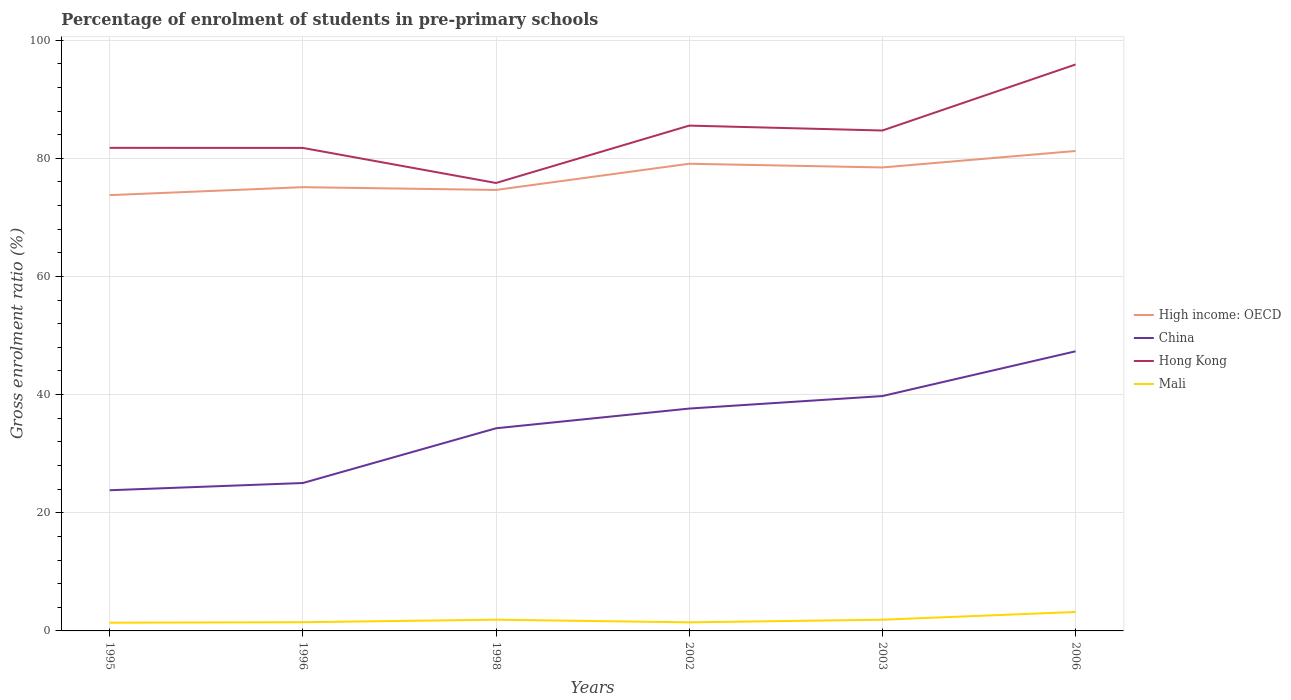How many different coloured lines are there?
Offer a very short reply. 4. Does the line corresponding to Hong Kong intersect with the line corresponding to High income: OECD?
Your answer should be very brief. No. Is the number of lines equal to the number of legend labels?
Offer a very short reply. Yes. Across all years, what is the maximum percentage of students enrolled in pre-primary schools in Hong Kong?
Your answer should be compact. 75.83. What is the total percentage of students enrolled in pre-primary schools in Hong Kong in the graph?
Make the answer very short. 0.01. What is the difference between the highest and the second highest percentage of students enrolled in pre-primary schools in China?
Your answer should be compact. 23.52. Is the percentage of students enrolled in pre-primary schools in Hong Kong strictly greater than the percentage of students enrolled in pre-primary schools in Mali over the years?
Your response must be concise. No. What is the difference between two consecutive major ticks on the Y-axis?
Give a very brief answer. 20. Are the values on the major ticks of Y-axis written in scientific E-notation?
Your response must be concise. No. Does the graph contain any zero values?
Provide a succinct answer. No. What is the title of the graph?
Make the answer very short. Percentage of enrolment of students in pre-primary schools. What is the label or title of the X-axis?
Your response must be concise. Years. What is the Gross enrolment ratio (%) of High income: OECD in 1995?
Offer a terse response. 73.77. What is the Gross enrolment ratio (%) in China in 1995?
Offer a very short reply. 23.81. What is the Gross enrolment ratio (%) in Hong Kong in 1995?
Provide a short and direct response. 81.78. What is the Gross enrolment ratio (%) of Mali in 1995?
Make the answer very short. 1.39. What is the Gross enrolment ratio (%) in High income: OECD in 1996?
Offer a very short reply. 75.12. What is the Gross enrolment ratio (%) of China in 1996?
Offer a terse response. 25.04. What is the Gross enrolment ratio (%) of Hong Kong in 1996?
Your answer should be very brief. 81.76. What is the Gross enrolment ratio (%) of Mali in 1996?
Provide a short and direct response. 1.47. What is the Gross enrolment ratio (%) in High income: OECD in 1998?
Keep it short and to the point. 74.65. What is the Gross enrolment ratio (%) in China in 1998?
Offer a very short reply. 34.31. What is the Gross enrolment ratio (%) in Hong Kong in 1998?
Offer a very short reply. 75.83. What is the Gross enrolment ratio (%) of Mali in 1998?
Offer a terse response. 1.9. What is the Gross enrolment ratio (%) in High income: OECD in 2002?
Your response must be concise. 79.08. What is the Gross enrolment ratio (%) in China in 2002?
Provide a succinct answer. 37.64. What is the Gross enrolment ratio (%) in Hong Kong in 2002?
Offer a very short reply. 85.54. What is the Gross enrolment ratio (%) in Mali in 2002?
Your answer should be very brief. 1.45. What is the Gross enrolment ratio (%) of High income: OECD in 2003?
Offer a very short reply. 78.46. What is the Gross enrolment ratio (%) in China in 2003?
Ensure brevity in your answer.  39.76. What is the Gross enrolment ratio (%) in Hong Kong in 2003?
Ensure brevity in your answer.  84.71. What is the Gross enrolment ratio (%) in Mali in 2003?
Your answer should be very brief. 1.9. What is the Gross enrolment ratio (%) in High income: OECD in 2006?
Offer a very short reply. 81.24. What is the Gross enrolment ratio (%) in China in 2006?
Keep it short and to the point. 47.34. What is the Gross enrolment ratio (%) in Hong Kong in 2006?
Give a very brief answer. 95.89. What is the Gross enrolment ratio (%) in Mali in 2006?
Offer a terse response. 3.21. Across all years, what is the maximum Gross enrolment ratio (%) in High income: OECD?
Make the answer very short. 81.24. Across all years, what is the maximum Gross enrolment ratio (%) in China?
Offer a terse response. 47.34. Across all years, what is the maximum Gross enrolment ratio (%) of Hong Kong?
Offer a terse response. 95.89. Across all years, what is the maximum Gross enrolment ratio (%) in Mali?
Offer a very short reply. 3.21. Across all years, what is the minimum Gross enrolment ratio (%) in High income: OECD?
Offer a very short reply. 73.77. Across all years, what is the minimum Gross enrolment ratio (%) of China?
Provide a short and direct response. 23.81. Across all years, what is the minimum Gross enrolment ratio (%) of Hong Kong?
Keep it short and to the point. 75.83. Across all years, what is the minimum Gross enrolment ratio (%) of Mali?
Provide a succinct answer. 1.39. What is the total Gross enrolment ratio (%) of High income: OECD in the graph?
Your answer should be very brief. 462.32. What is the total Gross enrolment ratio (%) of China in the graph?
Your response must be concise. 207.89. What is the total Gross enrolment ratio (%) in Hong Kong in the graph?
Offer a very short reply. 505.5. What is the total Gross enrolment ratio (%) in Mali in the graph?
Give a very brief answer. 11.33. What is the difference between the Gross enrolment ratio (%) in High income: OECD in 1995 and that in 1996?
Your response must be concise. -1.35. What is the difference between the Gross enrolment ratio (%) in China in 1995 and that in 1996?
Provide a short and direct response. -1.22. What is the difference between the Gross enrolment ratio (%) of Hong Kong in 1995 and that in 1996?
Give a very brief answer. 0.01. What is the difference between the Gross enrolment ratio (%) in Mali in 1995 and that in 1996?
Your answer should be compact. -0.08. What is the difference between the Gross enrolment ratio (%) in High income: OECD in 1995 and that in 1998?
Offer a very short reply. -0.88. What is the difference between the Gross enrolment ratio (%) in China in 1995 and that in 1998?
Ensure brevity in your answer.  -10.49. What is the difference between the Gross enrolment ratio (%) of Hong Kong in 1995 and that in 1998?
Keep it short and to the point. 5.95. What is the difference between the Gross enrolment ratio (%) in Mali in 1995 and that in 1998?
Make the answer very short. -0.51. What is the difference between the Gross enrolment ratio (%) in High income: OECD in 1995 and that in 2002?
Ensure brevity in your answer.  -5.31. What is the difference between the Gross enrolment ratio (%) of China in 1995 and that in 2002?
Your answer should be very brief. -13.83. What is the difference between the Gross enrolment ratio (%) in Hong Kong in 1995 and that in 2002?
Keep it short and to the point. -3.76. What is the difference between the Gross enrolment ratio (%) of Mali in 1995 and that in 2002?
Your answer should be very brief. -0.06. What is the difference between the Gross enrolment ratio (%) of High income: OECD in 1995 and that in 2003?
Make the answer very short. -4.69. What is the difference between the Gross enrolment ratio (%) of China in 1995 and that in 2003?
Give a very brief answer. -15.94. What is the difference between the Gross enrolment ratio (%) of Hong Kong in 1995 and that in 2003?
Offer a terse response. -2.94. What is the difference between the Gross enrolment ratio (%) in Mali in 1995 and that in 2003?
Provide a short and direct response. -0.51. What is the difference between the Gross enrolment ratio (%) of High income: OECD in 1995 and that in 2006?
Your answer should be compact. -7.47. What is the difference between the Gross enrolment ratio (%) of China in 1995 and that in 2006?
Provide a succinct answer. -23.52. What is the difference between the Gross enrolment ratio (%) in Hong Kong in 1995 and that in 2006?
Ensure brevity in your answer.  -14.11. What is the difference between the Gross enrolment ratio (%) of Mali in 1995 and that in 2006?
Make the answer very short. -1.81. What is the difference between the Gross enrolment ratio (%) in High income: OECD in 1996 and that in 1998?
Ensure brevity in your answer.  0.47. What is the difference between the Gross enrolment ratio (%) in China in 1996 and that in 1998?
Provide a short and direct response. -9.27. What is the difference between the Gross enrolment ratio (%) in Hong Kong in 1996 and that in 1998?
Make the answer very short. 5.93. What is the difference between the Gross enrolment ratio (%) in Mali in 1996 and that in 1998?
Your answer should be very brief. -0.43. What is the difference between the Gross enrolment ratio (%) in High income: OECD in 1996 and that in 2002?
Ensure brevity in your answer.  -3.97. What is the difference between the Gross enrolment ratio (%) in China in 1996 and that in 2002?
Your answer should be compact. -12.6. What is the difference between the Gross enrolment ratio (%) in Hong Kong in 1996 and that in 2002?
Keep it short and to the point. -3.78. What is the difference between the Gross enrolment ratio (%) in Mali in 1996 and that in 2002?
Give a very brief answer. 0.02. What is the difference between the Gross enrolment ratio (%) of High income: OECD in 1996 and that in 2003?
Your answer should be very brief. -3.34. What is the difference between the Gross enrolment ratio (%) of China in 1996 and that in 2003?
Keep it short and to the point. -14.72. What is the difference between the Gross enrolment ratio (%) in Hong Kong in 1996 and that in 2003?
Give a very brief answer. -2.95. What is the difference between the Gross enrolment ratio (%) of Mali in 1996 and that in 2003?
Make the answer very short. -0.42. What is the difference between the Gross enrolment ratio (%) in High income: OECD in 1996 and that in 2006?
Make the answer very short. -6.13. What is the difference between the Gross enrolment ratio (%) in China in 1996 and that in 2006?
Your answer should be compact. -22.3. What is the difference between the Gross enrolment ratio (%) in Hong Kong in 1996 and that in 2006?
Offer a very short reply. -14.12. What is the difference between the Gross enrolment ratio (%) in Mali in 1996 and that in 2006?
Ensure brevity in your answer.  -1.73. What is the difference between the Gross enrolment ratio (%) of High income: OECD in 1998 and that in 2002?
Your answer should be very brief. -4.43. What is the difference between the Gross enrolment ratio (%) of China in 1998 and that in 2002?
Give a very brief answer. -3.33. What is the difference between the Gross enrolment ratio (%) in Hong Kong in 1998 and that in 2002?
Offer a terse response. -9.71. What is the difference between the Gross enrolment ratio (%) of Mali in 1998 and that in 2002?
Your answer should be compact. 0.45. What is the difference between the Gross enrolment ratio (%) of High income: OECD in 1998 and that in 2003?
Keep it short and to the point. -3.81. What is the difference between the Gross enrolment ratio (%) of China in 1998 and that in 2003?
Keep it short and to the point. -5.45. What is the difference between the Gross enrolment ratio (%) in Hong Kong in 1998 and that in 2003?
Give a very brief answer. -8.88. What is the difference between the Gross enrolment ratio (%) of Mali in 1998 and that in 2003?
Provide a short and direct response. 0. What is the difference between the Gross enrolment ratio (%) of High income: OECD in 1998 and that in 2006?
Make the answer very short. -6.59. What is the difference between the Gross enrolment ratio (%) in China in 1998 and that in 2006?
Keep it short and to the point. -13.03. What is the difference between the Gross enrolment ratio (%) of Hong Kong in 1998 and that in 2006?
Make the answer very short. -20.06. What is the difference between the Gross enrolment ratio (%) of Mali in 1998 and that in 2006?
Provide a succinct answer. -1.3. What is the difference between the Gross enrolment ratio (%) in High income: OECD in 2002 and that in 2003?
Keep it short and to the point. 0.63. What is the difference between the Gross enrolment ratio (%) in China in 2002 and that in 2003?
Offer a terse response. -2.12. What is the difference between the Gross enrolment ratio (%) of Hong Kong in 2002 and that in 2003?
Ensure brevity in your answer.  0.83. What is the difference between the Gross enrolment ratio (%) in Mali in 2002 and that in 2003?
Provide a short and direct response. -0.45. What is the difference between the Gross enrolment ratio (%) of High income: OECD in 2002 and that in 2006?
Your answer should be very brief. -2.16. What is the difference between the Gross enrolment ratio (%) of China in 2002 and that in 2006?
Offer a very short reply. -9.7. What is the difference between the Gross enrolment ratio (%) in Hong Kong in 2002 and that in 2006?
Your answer should be very brief. -10.35. What is the difference between the Gross enrolment ratio (%) in Mali in 2002 and that in 2006?
Make the answer very short. -1.75. What is the difference between the Gross enrolment ratio (%) in High income: OECD in 2003 and that in 2006?
Your answer should be very brief. -2.79. What is the difference between the Gross enrolment ratio (%) in China in 2003 and that in 2006?
Keep it short and to the point. -7.58. What is the difference between the Gross enrolment ratio (%) of Hong Kong in 2003 and that in 2006?
Ensure brevity in your answer.  -11.18. What is the difference between the Gross enrolment ratio (%) in Mali in 2003 and that in 2006?
Give a very brief answer. -1.31. What is the difference between the Gross enrolment ratio (%) of High income: OECD in 1995 and the Gross enrolment ratio (%) of China in 1996?
Keep it short and to the point. 48.73. What is the difference between the Gross enrolment ratio (%) of High income: OECD in 1995 and the Gross enrolment ratio (%) of Hong Kong in 1996?
Give a very brief answer. -7.99. What is the difference between the Gross enrolment ratio (%) of High income: OECD in 1995 and the Gross enrolment ratio (%) of Mali in 1996?
Ensure brevity in your answer.  72.3. What is the difference between the Gross enrolment ratio (%) of China in 1995 and the Gross enrolment ratio (%) of Hong Kong in 1996?
Your answer should be compact. -57.95. What is the difference between the Gross enrolment ratio (%) of China in 1995 and the Gross enrolment ratio (%) of Mali in 1996?
Your answer should be compact. 22.34. What is the difference between the Gross enrolment ratio (%) in Hong Kong in 1995 and the Gross enrolment ratio (%) in Mali in 1996?
Ensure brevity in your answer.  80.3. What is the difference between the Gross enrolment ratio (%) of High income: OECD in 1995 and the Gross enrolment ratio (%) of China in 1998?
Give a very brief answer. 39.46. What is the difference between the Gross enrolment ratio (%) of High income: OECD in 1995 and the Gross enrolment ratio (%) of Hong Kong in 1998?
Your response must be concise. -2.06. What is the difference between the Gross enrolment ratio (%) in High income: OECD in 1995 and the Gross enrolment ratio (%) in Mali in 1998?
Your answer should be very brief. 71.87. What is the difference between the Gross enrolment ratio (%) of China in 1995 and the Gross enrolment ratio (%) of Hong Kong in 1998?
Provide a succinct answer. -52.01. What is the difference between the Gross enrolment ratio (%) in China in 1995 and the Gross enrolment ratio (%) in Mali in 1998?
Ensure brevity in your answer.  21.91. What is the difference between the Gross enrolment ratio (%) of Hong Kong in 1995 and the Gross enrolment ratio (%) of Mali in 1998?
Ensure brevity in your answer.  79.87. What is the difference between the Gross enrolment ratio (%) of High income: OECD in 1995 and the Gross enrolment ratio (%) of China in 2002?
Keep it short and to the point. 36.13. What is the difference between the Gross enrolment ratio (%) of High income: OECD in 1995 and the Gross enrolment ratio (%) of Hong Kong in 2002?
Your answer should be very brief. -11.77. What is the difference between the Gross enrolment ratio (%) of High income: OECD in 1995 and the Gross enrolment ratio (%) of Mali in 2002?
Offer a very short reply. 72.32. What is the difference between the Gross enrolment ratio (%) of China in 1995 and the Gross enrolment ratio (%) of Hong Kong in 2002?
Provide a short and direct response. -61.72. What is the difference between the Gross enrolment ratio (%) of China in 1995 and the Gross enrolment ratio (%) of Mali in 2002?
Your response must be concise. 22.36. What is the difference between the Gross enrolment ratio (%) of Hong Kong in 1995 and the Gross enrolment ratio (%) of Mali in 2002?
Your response must be concise. 80.32. What is the difference between the Gross enrolment ratio (%) of High income: OECD in 1995 and the Gross enrolment ratio (%) of China in 2003?
Provide a succinct answer. 34.01. What is the difference between the Gross enrolment ratio (%) in High income: OECD in 1995 and the Gross enrolment ratio (%) in Hong Kong in 2003?
Offer a very short reply. -10.94. What is the difference between the Gross enrolment ratio (%) in High income: OECD in 1995 and the Gross enrolment ratio (%) in Mali in 2003?
Offer a terse response. 71.87. What is the difference between the Gross enrolment ratio (%) in China in 1995 and the Gross enrolment ratio (%) in Hong Kong in 2003?
Offer a terse response. -60.9. What is the difference between the Gross enrolment ratio (%) in China in 1995 and the Gross enrolment ratio (%) in Mali in 2003?
Ensure brevity in your answer.  21.92. What is the difference between the Gross enrolment ratio (%) in Hong Kong in 1995 and the Gross enrolment ratio (%) in Mali in 2003?
Ensure brevity in your answer.  79.88. What is the difference between the Gross enrolment ratio (%) of High income: OECD in 1995 and the Gross enrolment ratio (%) of China in 2006?
Offer a very short reply. 26.43. What is the difference between the Gross enrolment ratio (%) in High income: OECD in 1995 and the Gross enrolment ratio (%) in Hong Kong in 2006?
Provide a succinct answer. -22.12. What is the difference between the Gross enrolment ratio (%) in High income: OECD in 1995 and the Gross enrolment ratio (%) in Mali in 2006?
Provide a succinct answer. 70.56. What is the difference between the Gross enrolment ratio (%) of China in 1995 and the Gross enrolment ratio (%) of Hong Kong in 2006?
Offer a very short reply. -72.07. What is the difference between the Gross enrolment ratio (%) in China in 1995 and the Gross enrolment ratio (%) in Mali in 2006?
Give a very brief answer. 20.61. What is the difference between the Gross enrolment ratio (%) in Hong Kong in 1995 and the Gross enrolment ratio (%) in Mali in 2006?
Your answer should be very brief. 78.57. What is the difference between the Gross enrolment ratio (%) in High income: OECD in 1996 and the Gross enrolment ratio (%) in China in 1998?
Your answer should be compact. 40.81. What is the difference between the Gross enrolment ratio (%) of High income: OECD in 1996 and the Gross enrolment ratio (%) of Hong Kong in 1998?
Ensure brevity in your answer.  -0.71. What is the difference between the Gross enrolment ratio (%) in High income: OECD in 1996 and the Gross enrolment ratio (%) in Mali in 1998?
Keep it short and to the point. 73.22. What is the difference between the Gross enrolment ratio (%) of China in 1996 and the Gross enrolment ratio (%) of Hong Kong in 1998?
Your answer should be compact. -50.79. What is the difference between the Gross enrolment ratio (%) of China in 1996 and the Gross enrolment ratio (%) of Mali in 1998?
Keep it short and to the point. 23.13. What is the difference between the Gross enrolment ratio (%) of Hong Kong in 1996 and the Gross enrolment ratio (%) of Mali in 1998?
Your answer should be compact. 79.86. What is the difference between the Gross enrolment ratio (%) in High income: OECD in 1996 and the Gross enrolment ratio (%) in China in 2002?
Provide a succinct answer. 37.48. What is the difference between the Gross enrolment ratio (%) in High income: OECD in 1996 and the Gross enrolment ratio (%) in Hong Kong in 2002?
Offer a terse response. -10.42. What is the difference between the Gross enrolment ratio (%) in High income: OECD in 1996 and the Gross enrolment ratio (%) in Mali in 2002?
Provide a short and direct response. 73.67. What is the difference between the Gross enrolment ratio (%) of China in 1996 and the Gross enrolment ratio (%) of Hong Kong in 2002?
Make the answer very short. -60.5. What is the difference between the Gross enrolment ratio (%) of China in 1996 and the Gross enrolment ratio (%) of Mali in 2002?
Make the answer very short. 23.58. What is the difference between the Gross enrolment ratio (%) in Hong Kong in 1996 and the Gross enrolment ratio (%) in Mali in 2002?
Ensure brevity in your answer.  80.31. What is the difference between the Gross enrolment ratio (%) in High income: OECD in 1996 and the Gross enrolment ratio (%) in China in 2003?
Give a very brief answer. 35.36. What is the difference between the Gross enrolment ratio (%) of High income: OECD in 1996 and the Gross enrolment ratio (%) of Hong Kong in 2003?
Give a very brief answer. -9.59. What is the difference between the Gross enrolment ratio (%) of High income: OECD in 1996 and the Gross enrolment ratio (%) of Mali in 2003?
Offer a very short reply. 73.22. What is the difference between the Gross enrolment ratio (%) in China in 1996 and the Gross enrolment ratio (%) in Hong Kong in 2003?
Offer a very short reply. -59.67. What is the difference between the Gross enrolment ratio (%) of China in 1996 and the Gross enrolment ratio (%) of Mali in 2003?
Ensure brevity in your answer.  23.14. What is the difference between the Gross enrolment ratio (%) in Hong Kong in 1996 and the Gross enrolment ratio (%) in Mali in 2003?
Offer a terse response. 79.86. What is the difference between the Gross enrolment ratio (%) in High income: OECD in 1996 and the Gross enrolment ratio (%) in China in 2006?
Give a very brief answer. 27.78. What is the difference between the Gross enrolment ratio (%) of High income: OECD in 1996 and the Gross enrolment ratio (%) of Hong Kong in 2006?
Provide a succinct answer. -20.77. What is the difference between the Gross enrolment ratio (%) of High income: OECD in 1996 and the Gross enrolment ratio (%) of Mali in 2006?
Keep it short and to the point. 71.91. What is the difference between the Gross enrolment ratio (%) in China in 1996 and the Gross enrolment ratio (%) in Hong Kong in 2006?
Your answer should be compact. -70.85. What is the difference between the Gross enrolment ratio (%) in China in 1996 and the Gross enrolment ratio (%) in Mali in 2006?
Your response must be concise. 21.83. What is the difference between the Gross enrolment ratio (%) of Hong Kong in 1996 and the Gross enrolment ratio (%) of Mali in 2006?
Offer a terse response. 78.56. What is the difference between the Gross enrolment ratio (%) in High income: OECD in 1998 and the Gross enrolment ratio (%) in China in 2002?
Ensure brevity in your answer.  37.01. What is the difference between the Gross enrolment ratio (%) in High income: OECD in 1998 and the Gross enrolment ratio (%) in Hong Kong in 2002?
Your answer should be compact. -10.89. What is the difference between the Gross enrolment ratio (%) of High income: OECD in 1998 and the Gross enrolment ratio (%) of Mali in 2002?
Ensure brevity in your answer.  73.2. What is the difference between the Gross enrolment ratio (%) of China in 1998 and the Gross enrolment ratio (%) of Hong Kong in 2002?
Keep it short and to the point. -51.23. What is the difference between the Gross enrolment ratio (%) in China in 1998 and the Gross enrolment ratio (%) in Mali in 2002?
Your answer should be compact. 32.85. What is the difference between the Gross enrolment ratio (%) in Hong Kong in 1998 and the Gross enrolment ratio (%) in Mali in 2002?
Your response must be concise. 74.38. What is the difference between the Gross enrolment ratio (%) of High income: OECD in 1998 and the Gross enrolment ratio (%) of China in 2003?
Your response must be concise. 34.89. What is the difference between the Gross enrolment ratio (%) of High income: OECD in 1998 and the Gross enrolment ratio (%) of Hong Kong in 2003?
Keep it short and to the point. -10.06. What is the difference between the Gross enrolment ratio (%) in High income: OECD in 1998 and the Gross enrolment ratio (%) in Mali in 2003?
Provide a short and direct response. 72.75. What is the difference between the Gross enrolment ratio (%) of China in 1998 and the Gross enrolment ratio (%) of Hong Kong in 2003?
Your answer should be very brief. -50.41. What is the difference between the Gross enrolment ratio (%) of China in 1998 and the Gross enrolment ratio (%) of Mali in 2003?
Offer a terse response. 32.41. What is the difference between the Gross enrolment ratio (%) in Hong Kong in 1998 and the Gross enrolment ratio (%) in Mali in 2003?
Your answer should be compact. 73.93. What is the difference between the Gross enrolment ratio (%) in High income: OECD in 1998 and the Gross enrolment ratio (%) in China in 2006?
Your response must be concise. 27.31. What is the difference between the Gross enrolment ratio (%) of High income: OECD in 1998 and the Gross enrolment ratio (%) of Hong Kong in 2006?
Provide a short and direct response. -21.24. What is the difference between the Gross enrolment ratio (%) of High income: OECD in 1998 and the Gross enrolment ratio (%) of Mali in 2006?
Keep it short and to the point. 71.44. What is the difference between the Gross enrolment ratio (%) of China in 1998 and the Gross enrolment ratio (%) of Hong Kong in 2006?
Make the answer very short. -61.58. What is the difference between the Gross enrolment ratio (%) in China in 1998 and the Gross enrolment ratio (%) in Mali in 2006?
Ensure brevity in your answer.  31.1. What is the difference between the Gross enrolment ratio (%) in Hong Kong in 1998 and the Gross enrolment ratio (%) in Mali in 2006?
Ensure brevity in your answer.  72.62. What is the difference between the Gross enrolment ratio (%) in High income: OECD in 2002 and the Gross enrolment ratio (%) in China in 2003?
Keep it short and to the point. 39.33. What is the difference between the Gross enrolment ratio (%) in High income: OECD in 2002 and the Gross enrolment ratio (%) in Hong Kong in 2003?
Make the answer very short. -5.63. What is the difference between the Gross enrolment ratio (%) in High income: OECD in 2002 and the Gross enrolment ratio (%) in Mali in 2003?
Ensure brevity in your answer.  77.19. What is the difference between the Gross enrolment ratio (%) of China in 2002 and the Gross enrolment ratio (%) of Hong Kong in 2003?
Offer a very short reply. -47.07. What is the difference between the Gross enrolment ratio (%) in China in 2002 and the Gross enrolment ratio (%) in Mali in 2003?
Make the answer very short. 35.74. What is the difference between the Gross enrolment ratio (%) in Hong Kong in 2002 and the Gross enrolment ratio (%) in Mali in 2003?
Offer a terse response. 83.64. What is the difference between the Gross enrolment ratio (%) in High income: OECD in 2002 and the Gross enrolment ratio (%) in China in 2006?
Provide a short and direct response. 31.75. What is the difference between the Gross enrolment ratio (%) in High income: OECD in 2002 and the Gross enrolment ratio (%) in Hong Kong in 2006?
Your answer should be very brief. -16.8. What is the difference between the Gross enrolment ratio (%) in High income: OECD in 2002 and the Gross enrolment ratio (%) in Mali in 2006?
Provide a short and direct response. 75.88. What is the difference between the Gross enrolment ratio (%) in China in 2002 and the Gross enrolment ratio (%) in Hong Kong in 2006?
Your answer should be very brief. -58.25. What is the difference between the Gross enrolment ratio (%) in China in 2002 and the Gross enrolment ratio (%) in Mali in 2006?
Offer a very short reply. 34.43. What is the difference between the Gross enrolment ratio (%) of Hong Kong in 2002 and the Gross enrolment ratio (%) of Mali in 2006?
Ensure brevity in your answer.  82.33. What is the difference between the Gross enrolment ratio (%) of High income: OECD in 2003 and the Gross enrolment ratio (%) of China in 2006?
Keep it short and to the point. 31.12. What is the difference between the Gross enrolment ratio (%) in High income: OECD in 2003 and the Gross enrolment ratio (%) in Hong Kong in 2006?
Provide a succinct answer. -17.43. What is the difference between the Gross enrolment ratio (%) of High income: OECD in 2003 and the Gross enrolment ratio (%) of Mali in 2006?
Offer a terse response. 75.25. What is the difference between the Gross enrolment ratio (%) in China in 2003 and the Gross enrolment ratio (%) in Hong Kong in 2006?
Your answer should be compact. -56.13. What is the difference between the Gross enrolment ratio (%) in China in 2003 and the Gross enrolment ratio (%) in Mali in 2006?
Give a very brief answer. 36.55. What is the difference between the Gross enrolment ratio (%) in Hong Kong in 2003 and the Gross enrolment ratio (%) in Mali in 2006?
Offer a terse response. 81.5. What is the average Gross enrolment ratio (%) in High income: OECD per year?
Your response must be concise. 77.05. What is the average Gross enrolment ratio (%) of China per year?
Keep it short and to the point. 34.65. What is the average Gross enrolment ratio (%) of Hong Kong per year?
Make the answer very short. 84.25. What is the average Gross enrolment ratio (%) in Mali per year?
Your response must be concise. 1.89. In the year 1995, what is the difference between the Gross enrolment ratio (%) in High income: OECD and Gross enrolment ratio (%) in China?
Your answer should be very brief. 49.96. In the year 1995, what is the difference between the Gross enrolment ratio (%) of High income: OECD and Gross enrolment ratio (%) of Hong Kong?
Offer a very short reply. -8. In the year 1995, what is the difference between the Gross enrolment ratio (%) of High income: OECD and Gross enrolment ratio (%) of Mali?
Offer a very short reply. 72.38. In the year 1995, what is the difference between the Gross enrolment ratio (%) in China and Gross enrolment ratio (%) in Hong Kong?
Keep it short and to the point. -57.96. In the year 1995, what is the difference between the Gross enrolment ratio (%) in China and Gross enrolment ratio (%) in Mali?
Ensure brevity in your answer.  22.42. In the year 1995, what is the difference between the Gross enrolment ratio (%) of Hong Kong and Gross enrolment ratio (%) of Mali?
Ensure brevity in your answer.  80.38. In the year 1996, what is the difference between the Gross enrolment ratio (%) in High income: OECD and Gross enrolment ratio (%) in China?
Offer a very short reply. 50.08. In the year 1996, what is the difference between the Gross enrolment ratio (%) of High income: OECD and Gross enrolment ratio (%) of Hong Kong?
Keep it short and to the point. -6.64. In the year 1996, what is the difference between the Gross enrolment ratio (%) of High income: OECD and Gross enrolment ratio (%) of Mali?
Keep it short and to the point. 73.64. In the year 1996, what is the difference between the Gross enrolment ratio (%) in China and Gross enrolment ratio (%) in Hong Kong?
Your answer should be very brief. -56.73. In the year 1996, what is the difference between the Gross enrolment ratio (%) in China and Gross enrolment ratio (%) in Mali?
Give a very brief answer. 23.56. In the year 1996, what is the difference between the Gross enrolment ratio (%) of Hong Kong and Gross enrolment ratio (%) of Mali?
Provide a short and direct response. 80.29. In the year 1998, what is the difference between the Gross enrolment ratio (%) in High income: OECD and Gross enrolment ratio (%) in China?
Your answer should be very brief. 40.34. In the year 1998, what is the difference between the Gross enrolment ratio (%) in High income: OECD and Gross enrolment ratio (%) in Hong Kong?
Your answer should be compact. -1.18. In the year 1998, what is the difference between the Gross enrolment ratio (%) of High income: OECD and Gross enrolment ratio (%) of Mali?
Offer a very short reply. 72.75. In the year 1998, what is the difference between the Gross enrolment ratio (%) in China and Gross enrolment ratio (%) in Hong Kong?
Your answer should be compact. -41.52. In the year 1998, what is the difference between the Gross enrolment ratio (%) of China and Gross enrolment ratio (%) of Mali?
Offer a terse response. 32.4. In the year 1998, what is the difference between the Gross enrolment ratio (%) in Hong Kong and Gross enrolment ratio (%) in Mali?
Your answer should be very brief. 73.92. In the year 2002, what is the difference between the Gross enrolment ratio (%) in High income: OECD and Gross enrolment ratio (%) in China?
Make the answer very short. 41.44. In the year 2002, what is the difference between the Gross enrolment ratio (%) in High income: OECD and Gross enrolment ratio (%) in Hong Kong?
Make the answer very short. -6.45. In the year 2002, what is the difference between the Gross enrolment ratio (%) in High income: OECD and Gross enrolment ratio (%) in Mali?
Your answer should be very brief. 77.63. In the year 2002, what is the difference between the Gross enrolment ratio (%) of China and Gross enrolment ratio (%) of Hong Kong?
Your answer should be compact. -47.9. In the year 2002, what is the difference between the Gross enrolment ratio (%) in China and Gross enrolment ratio (%) in Mali?
Offer a terse response. 36.19. In the year 2002, what is the difference between the Gross enrolment ratio (%) of Hong Kong and Gross enrolment ratio (%) of Mali?
Keep it short and to the point. 84.09. In the year 2003, what is the difference between the Gross enrolment ratio (%) of High income: OECD and Gross enrolment ratio (%) of China?
Give a very brief answer. 38.7. In the year 2003, what is the difference between the Gross enrolment ratio (%) of High income: OECD and Gross enrolment ratio (%) of Hong Kong?
Give a very brief answer. -6.25. In the year 2003, what is the difference between the Gross enrolment ratio (%) in High income: OECD and Gross enrolment ratio (%) in Mali?
Offer a very short reply. 76.56. In the year 2003, what is the difference between the Gross enrolment ratio (%) in China and Gross enrolment ratio (%) in Hong Kong?
Your answer should be very brief. -44.95. In the year 2003, what is the difference between the Gross enrolment ratio (%) in China and Gross enrolment ratio (%) in Mali?
Your answer should be very brief. 37.86. In the year 2003, what is the difference between the Gross enrolment ratio (%) of Hong Kong and Gross enrolment ratio (%) of Mali?
Provide a short and direct response. 82.81. In the year 2006, what is the difference between the Gross enrolment ratio (%) in High income: OECD and Gross enrolment ratio (%) in China?
Offer a very short reply. 33.91. In the year 2006, what is the difference between the Gross enrolment ratio (%) in High income: OECD and Gross enrolment ratio (%) in Hong Kong?
Keep it short and to the point. -14.64. In the year 2006, what is the difference between the Gross enrolment ratio (%) of High income: OECD and Gross enrolment ratio (%) of Mali?
Ensure brevity in your answer.  78.04. In the year 2006, what is the difference between the Gross enrolment ratio (%) of China and Gross enrolment ratio (%) of Hong Kong?
Offer a terse response. -48.55. In the year 2006, what is the difference between the Gross enrolment ratio (%) in China and Gross enrolment ratio (%) in Mali?
Offer a very short reply. 44.13. In the year 2006, what is the difference between the Gross enrolment ratio (%) in Hong Kong and Gross enrolment ratio (%) in Mali?
Give a very brief answer. 92.68. What is the ratio of the Gross enrolment ratio (%) in High income: OECD in 1995 to that in 1996?
Make the answer very short. 0.98. What is the ratio of the Gross enrolment ratio (%) in China in 1995 to that in 1996?
Offer a very short reply. 0.95. What is the ratio of the Gross enrolment ratio (%) in Mali in 1995 to that in 1996?
Your answer should be very brief. 0.94. What is the ratio of the Gross enrolment ratio (%) of High income: OECD in 1995 to that in 1998?
Make the answer very short. 0.99. What is the ratio of the Gross enrolment ratio (%) in China in 1995 to that in 1998?
Your answer should be very brief. 0.69. What is the ratio of the Gross enrolment ratio (%) in Hong Kong in 1995 to that in 1998?
Give a very brief answer. 1.08. What is the ratio of the Gross enrolment ratio (%) of Mali in 1995 to that in 1998?
Ensure brevity in your answer.  0.73. What is the ratio of the Gross enrolment ratio (%) of High income: OECD in 1995 to that in 2002?
Provide a short and direct response. 0.93. What is the ratio of the Gross enrolment ratio (%) of China in 1995 to that in 2002?
Make the answer very short. 0.63. What is the ratio of the Gross enrolment ratio (%) in Hong Kong in 1995 to that in 2002?
Offer a very short reply. 0.96. What is the ratio of the Gross enrolment ratio (%) of Mali in 1995 to that in 2002?
Give a very brief answer. 0.96. What is the ratio of the Gross enrolment ratio (%) in High income: OECD in 1995 to that in 2003?
Offer a terse response. 0.94. What is the ratio of the Gross enrolment ratio (%) in China in 1995 to that in 2003?
Your answer should be compact. 0.6. What is the ratio of the Gross enrolment ratio (%) in Hong Kong in 1995 to that in 2003?
Ensure brevity in your answer.  0.97. What is the ratio of the Gross enrolment ratio (%) of Mali in 1995 to that in 2003?
Offer a very short reply. 0.73. What is the ratio of the Gross enrolment ratio (%) of High income: OECD in 1995 to that in 2006?
Your answer should be compact. 0.91. What is the ratio of the Gross enrolment ratio (%) of China in 1995 to that in 2006?
Offer a terse response. 0.5. What is the ratio of the Gross enrolment ratio (%) of Hong Kong in 1995 to that in 2006?
Your answer should be compact. 0.85. What is the ratio of the Gross enrolment ratio (%) in Mali in 1995 to that in 2006?
Your response must be concise. 0.43. What is the ratio of the Gross enrolment ratio (%) of High income: OECD in 1996 to that in 1998?
Keep it short and to the point. 1.01. What is the ratio of the Gross enrolment ratio (%) of China in 1996 to that in 1998?
Give a very brief answer. 0.73. What is the ratio of the Gross enrolment ratio (%) of Hong Kong in 1996 to that in 1998?
Your response must be concise. 1.08. What is the ratio of the Gross enrolment ratio (%) in Mali in 1996 to that in 1998?
Your response must be concise. 0.77. What is the ratio of the Gross enrolment ratio (%) in High income: OECD in 1996 to that in 2002?
Your answer should be very brief. 0.95. What is the ratio of the Gross enrolment ratio (%) in China in 1996 to that in 2002?
Give a very brief answer. 0.67. What is the ratio of the Gross enrolment ratio (%) of Hong Kong in 1996 to that in 2002?
Make the answer very short. 0.96. What is the ratio of the Gross enrolment ratio (%) in Mali in 1996 to that in 2002?
Your answer should be compact. 1.01. What is the ratio of the Gross enrolment ratio (%) of High income: OECD in 1996 to that in 2003?
Offer a very short reply. 0.96. What is the ratio of the Gross enrolment ratio (%) of China in 1996 to that in 2003?
Your answer should be compact. 0.63. What is the ratio of the Gross enrolment ratio (%) of Hong Kong in 1996 to that in 2003?
Provide a succinct answer. 0.97. What is the ratio of the Gross enrolment ratio (%) of Mali in 1996 to that in 2003?
Provide a short and direct response. 0.78. What is the ratio of the Gross enrolment ratio (%) in High income: OECD in 1996 to that in 2006?
Ensure brevity in your answer.  0.92. What is the ratio of the Gross enrolment ratio (%) in China in 1996 to that in 2006?
Make the answer very short. 0.53. What is the ratio of the Gross enrolment ratio (%) in Hong Kong in 1996 to that in 2006?
Your answer should be very brief. 0.85. What is the ratio of the Gross enrolment ratio (%) in Mali in 1996 to that in 2006?
Make the answer very short. 0.46. What is the ratio of the Gross enrolment ratio (%) in High income: OECD in 1998 to that in 2002?
Provide a succinct answer. 0.94. What is the ratio of the Gross enrolment ratio (%) of China in 1998 to that in 2002?
Keep it short and to the point. 0.91. What is the ratio of the Gross enrolment ratio (%) of Hong Kong in 1998 to that in 2002?
Offer a very short reply. 0.89. What is the ratio of the Gross enrolment ratio (%) in Mali in 1998 to that in 2002?
Keep it short and to the point. 1.31. What is the ratio of the Gross enrolment ratio (%) in High income: OECD in 1998 to that in 2003?
Offer a terse response. 0.95. What is the ratio of the Gross enrolment ratio (%) of China in 1998 to that in 2003?
Make the answer very short. 0.86. What is the ratio of the Gross enrolment ratio (%) of Hong Kong in 1998 to that in 2003?
Provide a short and direct response. 0.9. What is the ratio of the Gross enrolment ratio (%) in High income: OECD in 1998 to that in 2006?
Your response must be concise. 0.92. What is the ratio of the Gross enrolment ratio (%) of China in 1998 to that in 2006?
Offer a terse response. 0.72. What is the ratio of the Gross enrolment ratio (%) of Hong Kong in 1998 to that in 2006?
Provide a succinct answer. 0.79. What is the ratio of the Gross enrolment ratio (%) of Mali in 1998 to that in 2006?
Ensure brevity in your answer.  0.59. What is the ratio of the Gross enrolment ratio (%) in High income: OECD in 2002 to that in 2003?
Your answer should be very brief. 1.01. What is the ratio of the Gross enrolment ratio (%) of China in 2002 to that in 2003?
Your answer should be very brief. 0.95. What is the ratio of the Gross enrolment ratio (%) in Hong Kong in 2002 to that in 2003?
Give a very brief answer. 1.01. What is the ratio of the Gross enrolment ratio (%) in Mali in 2002 to that in 2003?
Offer a terse response. 0.77. What is the ratio of the Gross enrolment ratio (%) in High income: OECD in 2002 to that in 2006?
Make the answer very short. 0.97. What is the ratio of the Gross enrolment ratio (%) in China in 2002 to that in 2006?
Provide a short and direct response. 0.8. What is the ratio of the Gross enrolment ratio (%) of Hong Kong in 2002 to that in 2006?
Give a very brief answer. 0.89. What is the ratio of the Gross enrolment ratio (%) of Mali in 2002 to that in 2006?
Offer a very short reply. 0.45. What is the ratio of the Gross enrolment ratio (%) of High income: OECD in 2003 to that in 2006?
Make the answer very short. 0.97. What is the ratio of the Gross enrolment ratio (%) of China in 2003 to that in 2006?
Give a very brief answer. 0.84. What is the ratio of the Gross enrolment ratio (%) of Hong Kong in 2003 to that in 2006?
Ensure brevity in your answer.  0.88. What is the ratio of the Gross enrolment ratio (%) of Mali in 2003 to that in 2006?
Give a very brief answer. 0.59. What is the difference between the highest and the second highest Gross enrolment ratio (%) of High income: OECD?
Provide a short and direct response. 2.16. What is the difference between the highest and the second highest Gross enrolment ratio (%) in China?
Provide a short and direct response. 7.58. What is the difference between the highest and the second highest Gross enrolment ratio (%) in Hong Kong?
Keep it short and to the point. 10.35. What is the difference between the highest and the second highest Gross enrolment ratio (%) in Mali?
Your answer should be very brief. 1.3. What is the difference between the highest and the lowest Gross enrolment ratio (%) of High income: OECD?
Provide a succinct answer. 7.47. What is the difference between the highest and the lowest Gross enrolment ratio (%) of China?
Your response must be concise. 23.52. What is the difference between the highest and the lowest Gross enrolment ratio (%) in Hong Kong?
Provide a short and direct response. 20.06. What is the difference between the highest and the lowest Gross enrolment ratio (%) of Mali?
Provide a succinct answer. 1.81. 